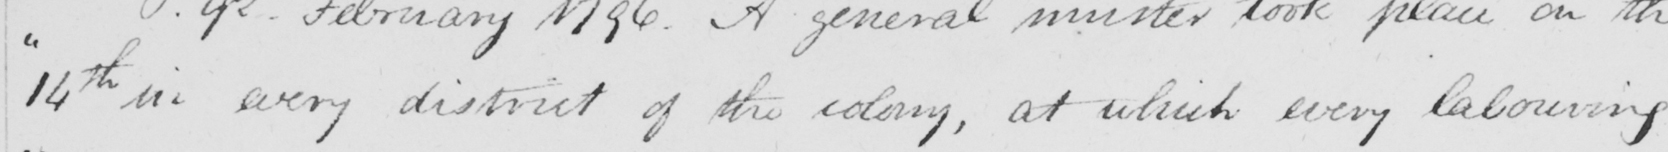Can you read and transcribe this handwriting? " 14th in every district of the colony , at which every labouring 